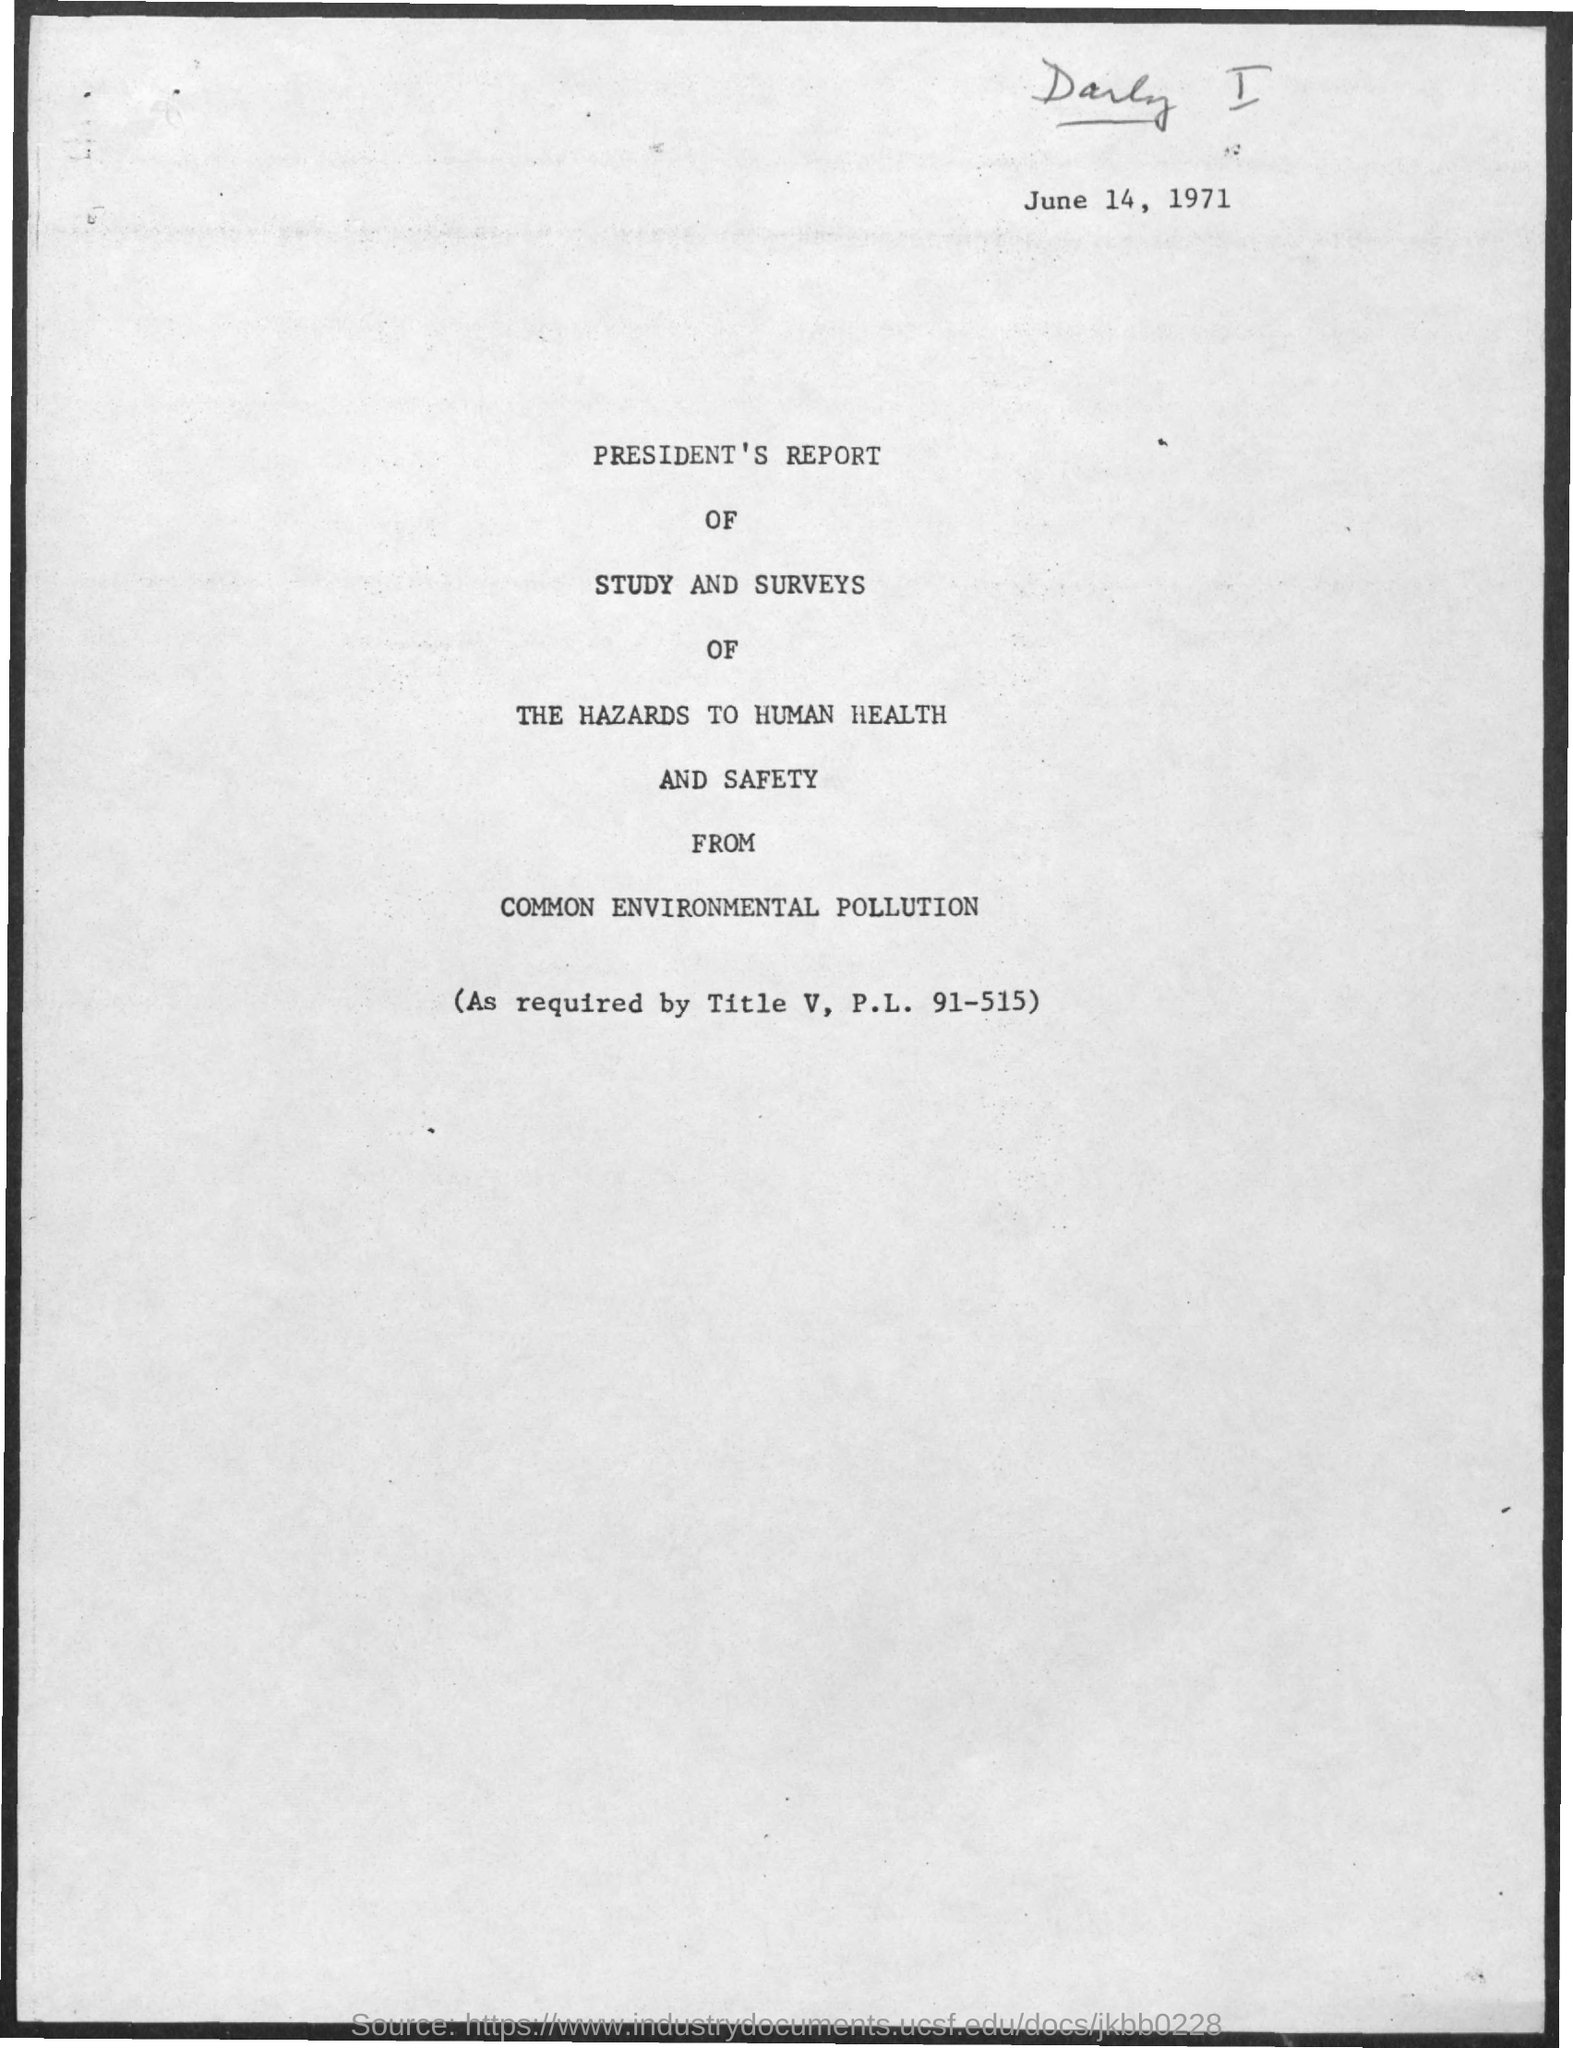Draw attention to some important aspects in this diagram. The date on the document is June 14, 1971. 